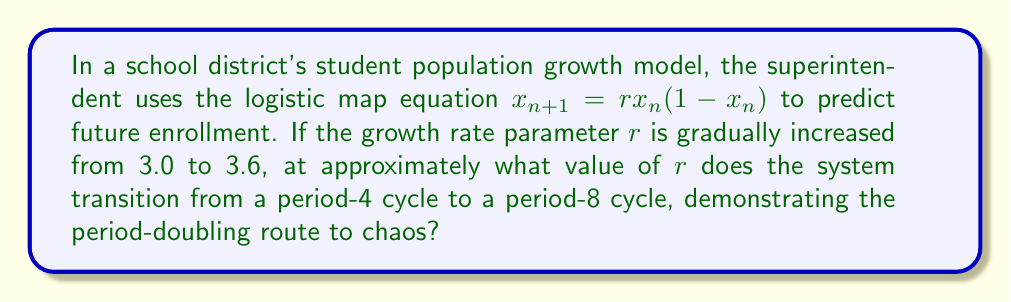Can you solve this math problem? To solve this problem, we need to understand the period-doubling cascade in the logistic map:

1) For $3 < r < 1 + \sqrt{6} \approx 3.45$, the system exhibits periodic behavior.

2) As $r$ increases, the system undergoes period-doubling bifurcations:
   - At $r \approx 3.45$, the system transitions from period-2 to period-4
   - At $r \approx 3.54$, the system transitions from period-4 to period-8
   - At $r \approx 3.564$, the system transitions from period-8 to period-16
   - This continues until chaos emerges at $r \approx 3.57$

3) The transition from period-4 to period-8 occurs at approximately $r = 3.54$.

4) This value can be calculated more precisely using the Feigenbaum constant $\delta \approx 4.669$, but for this level of precision, $r \approx 3.54$ is sufficient.

5) After this point, further period-doubling occurs rapidly, leading to chaos.
Answer: $r \approx 3.54$ 